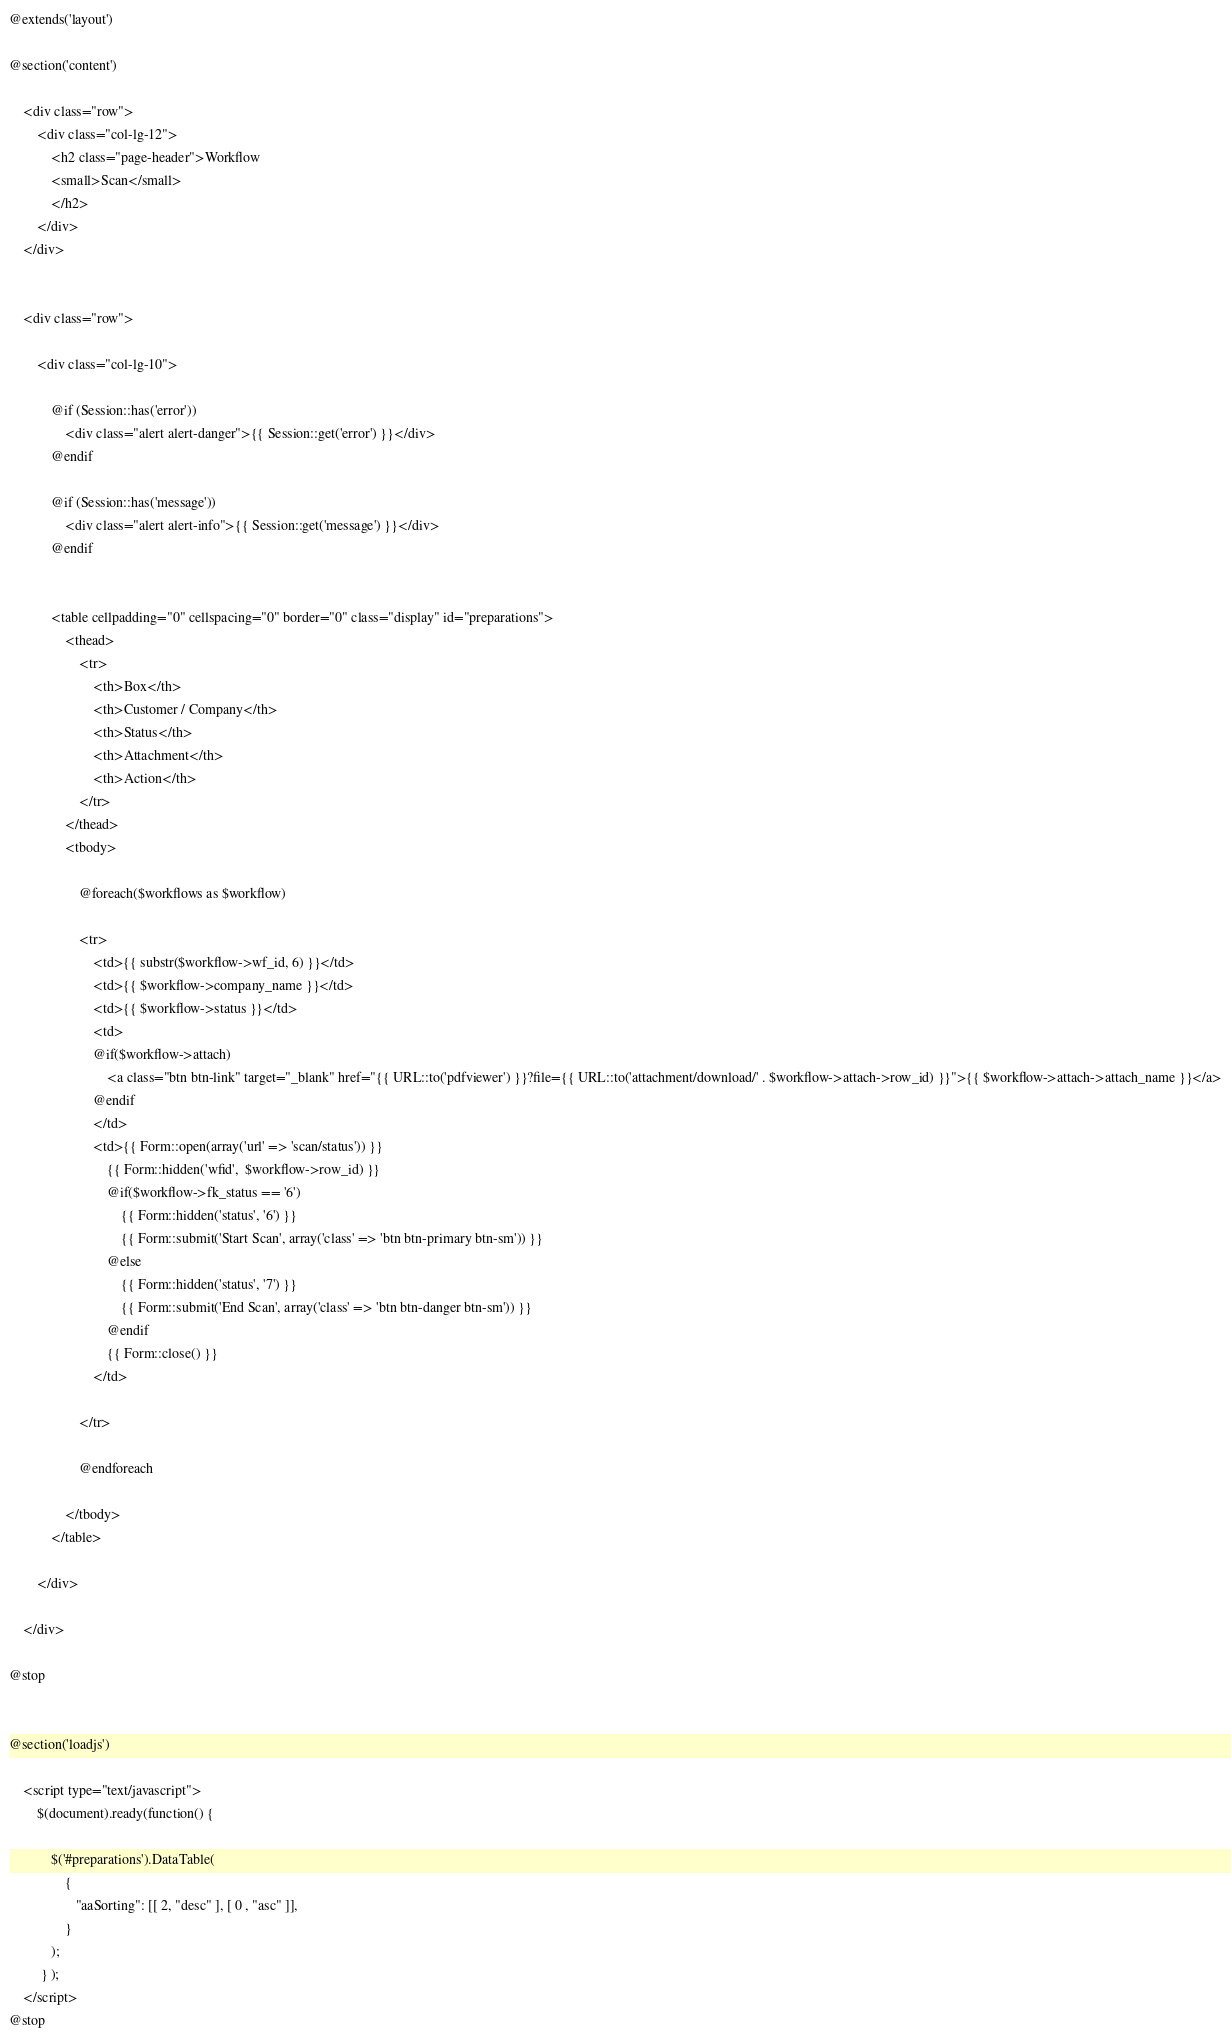<code> <loc_0><loc_0><loc_500><loc_500><_PHP_>@extends('layout')

@section('content')

	<div class="row">
		<div class="col-lg-12">
			<h2 class="page-header">Workflow 
			<small>Scan</small>
			</h2>
		</div>
	</div>
		
 
	<div class="row">
	
		<div class="col-lg-10">

			@if (Session::has('error'))
				<div class="alert alert-danger">{{ Session::get('error') }}</div>
			@endif
			
			@if (Session::has('message'))
				<div class="alert alert-info">{{ Session::get('message') }}</div>
			@endif
			

			<table cellpadding="0" cellspacing="0" border="0" class="display" id="preparations">
				<thead>
					<tr>
						<th>Box</th>
						<th>Customer / Company</th>
						<th>Status</th>
						<th>Attachment</th>
						<th>Action</th>						
					</tr>
				</thead>
				<tbody>
					
					@foreach($workflows as $workflow)
					
					<tr>			
						<td>{{ substr($workflow->wf_id, 6) }}</td>
						<td>{{ $workflow->company_name }}</td>
						<td>{{ $workflow->status }}</td>			
						<td>
						@if($workflow->attach)
							<a class="btn btn-link" target="_blank" href="{{ URL::to('pdfviewer') }}?file={{ URL::to('attachment/download/' . $workflow->attach->row_id) }}">{{ $workflow->attach->attach_name }}</a>
						@endif
						</td>
						<td>{{ Form::open(array('url' => 'scan/status')) }}
							{{ Form::hidden('wfid',  $workflow->row_id) }}
							@if($workflow->fk_status == '6')
								{{ Form::hidden('status', '6') }}
								{{ Form::submit('Start Scan', array('class' => 'btn btn-primary btn-sm')) }} 
						    @else
								{{ Form::hidden('status', '7') }}
							    {{ Form::submit('End Scan', array('class' => 'btn btn-danger btn-sm')) }}
							@endif
							{{ Form::close() }}
					    </td>
					 
					</tr>
						
					@endforeach
 
				</tbody>
			</table>

		</div>
			
	</div>

@stop


@section('loadjs')
	
	<script type="text/javascript">
		$(document).ready(function() {
		
			$('#preparations').DataTable(
				{
				   "aaSorting": [[ 2, "desc" ], [ 0 , "asc" ]],
				}
			);
		 } );
	</script>
@stop
</code> 